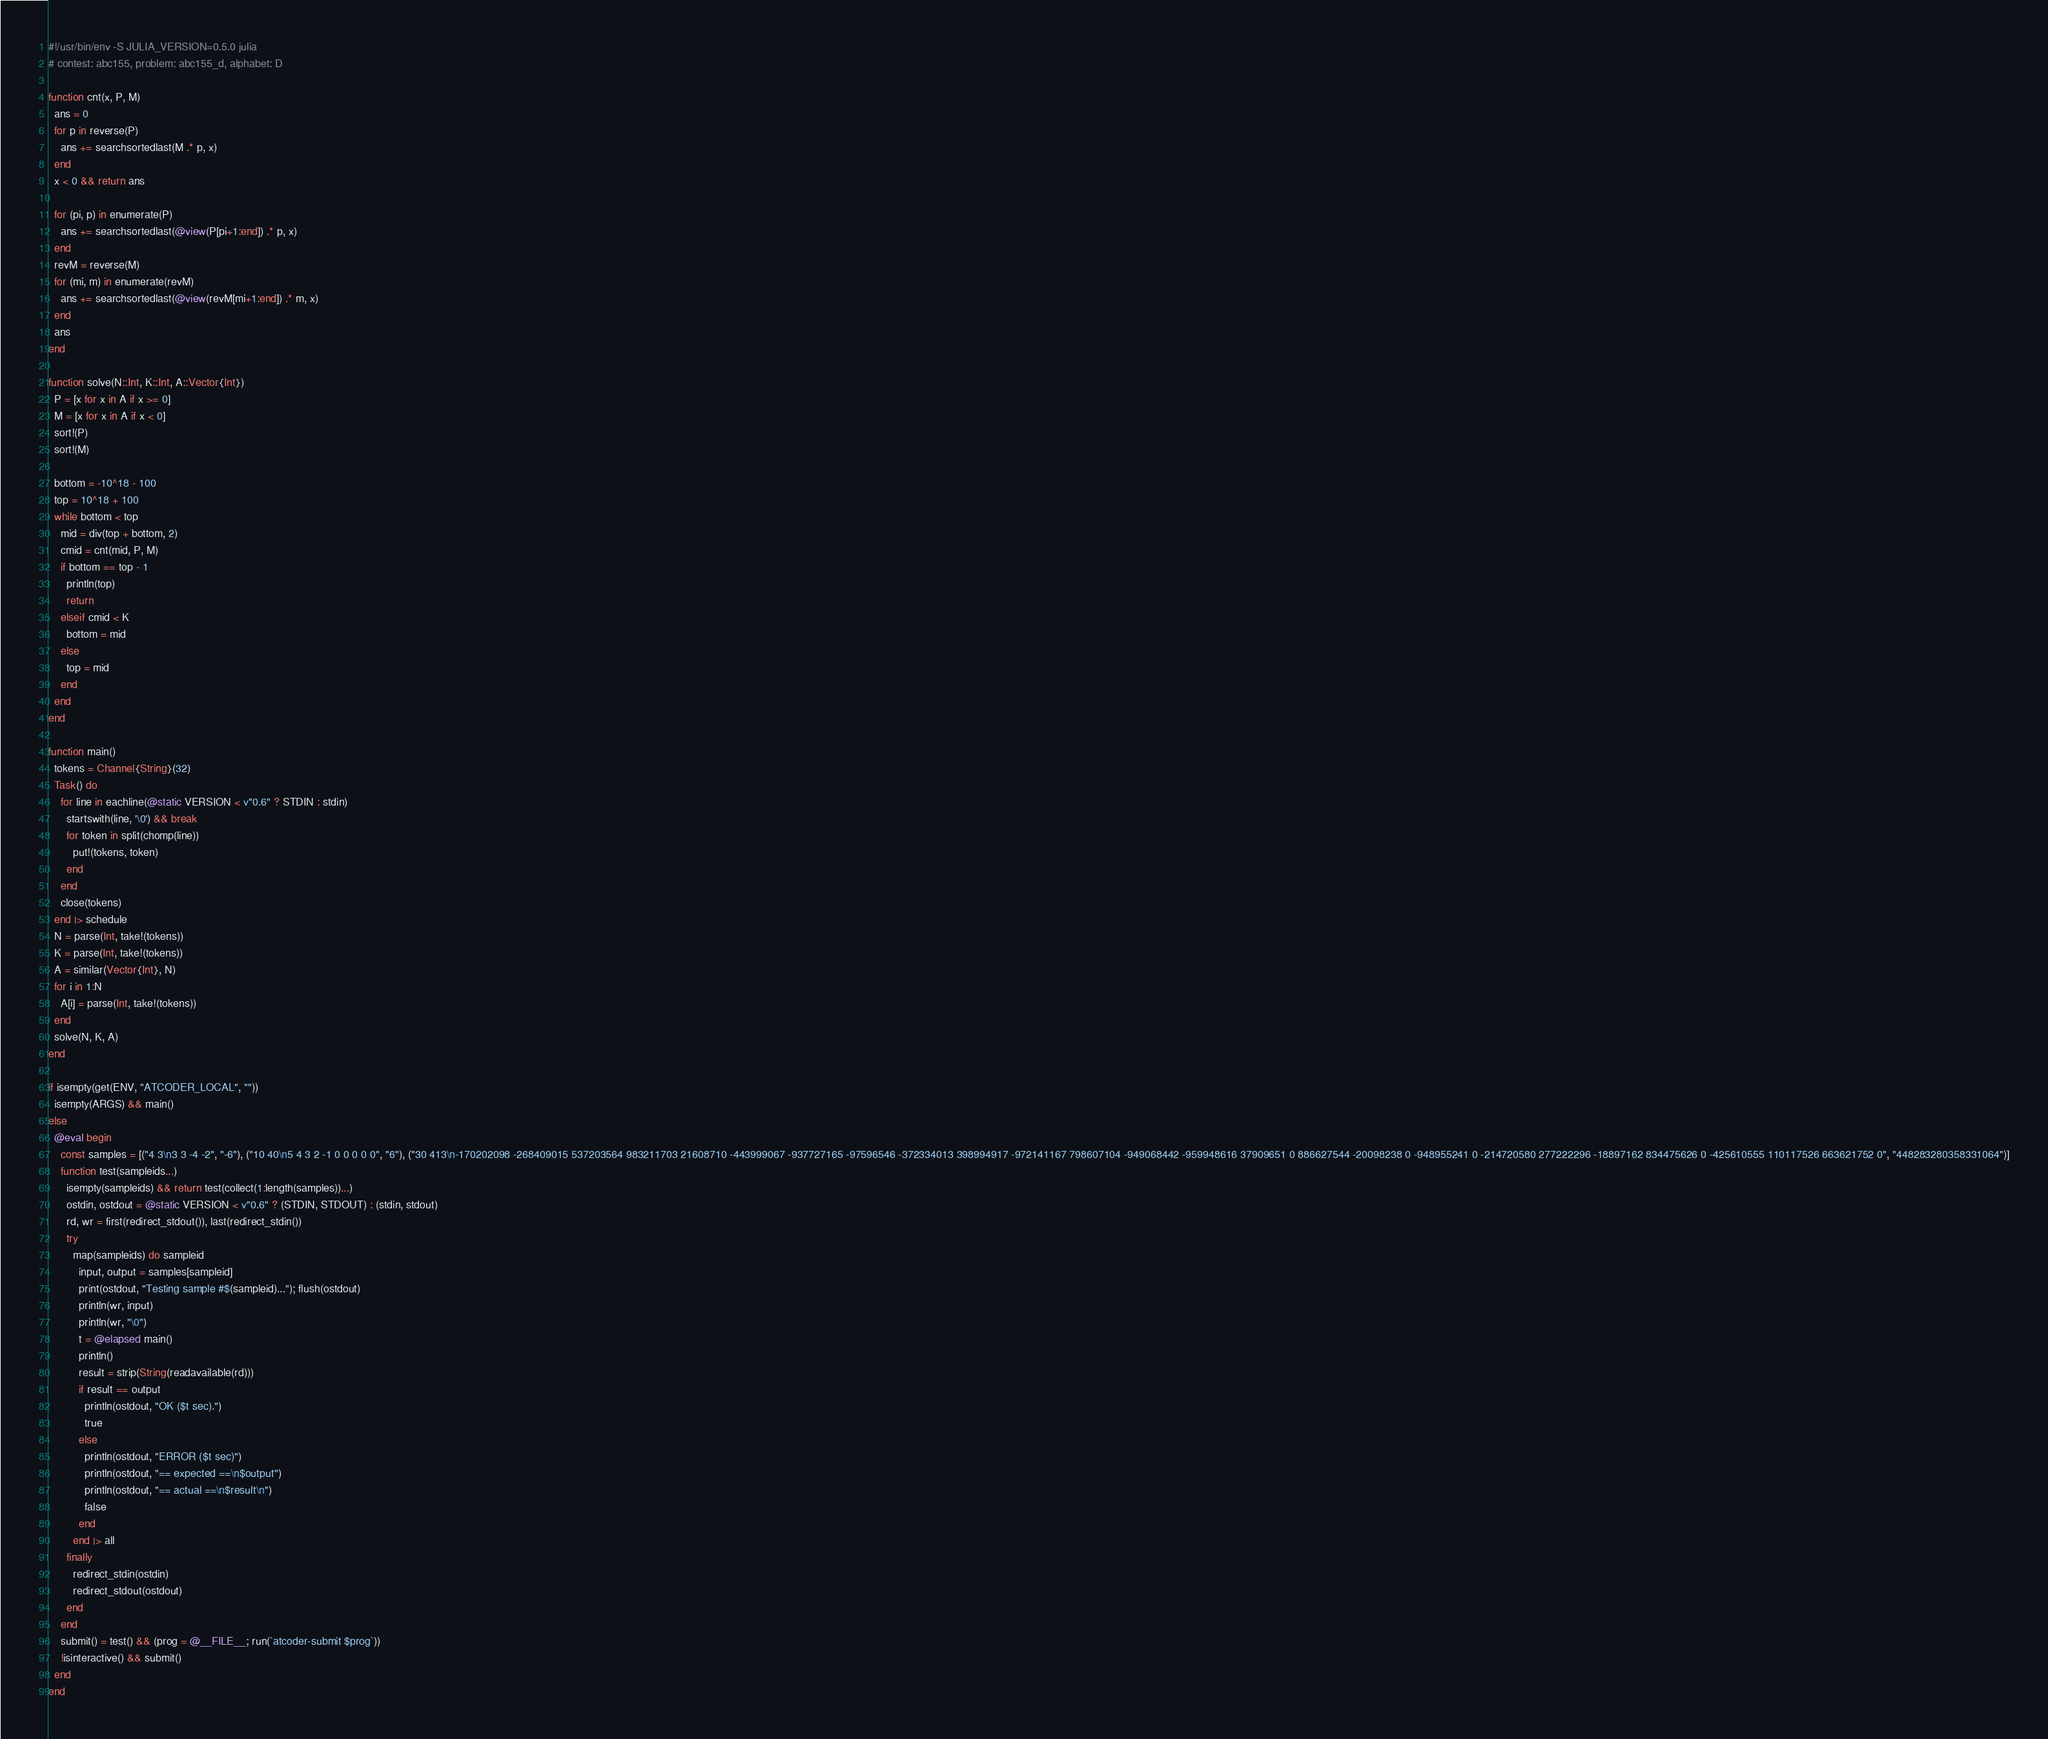Convert code to text. <code><loc_0><loc_0><loc_500><loc_500><_Julia_>#!/usr/bin/env -S JULIA_VERSION=0.5.0 julia
# contest: abc155, problem: abc155_d, alphabet: D

function cnt(x, P, M)
  ans = 0
  for p in reverse(P)
    ans += searchsortedlast(M .* p, x)
  end
  x < 0 && return ans

  for (pi, p) in enumerate(P)
    ans += searchsortedlast(@view(P[pi+1:end]) .* p, x)
  end
  revM = reverse(M)
  for (mi, m) in enumerate(revM)
    ans += searchsortedlast(@view(revM[mi+1:end]) .* m, x)
  end
  ans
end

function solve(N::Int, K::Int, A::Vector{Int})
  P = [x for x in A if x >= 0]
  M = [x for x in A if x < 0]
  sort!(P)
  sort!(M)

  bottom = -10^18 - 100
  top = 10^18 + 100
  while bottom < top
    mid = div(top + bottom, 2)
    cmid = cnt(mid, P, M)
    if bottom == top - 1
      println(top)
      return
    elseif cmid < K
      bottom = mid
    else
      top = mid
    end
  end
end

function main()
  tokens = Channel{String}(32)
  Task() do
    for line in eachline(@static VERSION < v"0.6" ? STDIN : stdin)
      startswith(line, '\0') && break
      for token in split(chomp(line))
        put!(tokens, token)
      end
    end
    close(tokens)
  end |> schedule
  N = parse(Int, take!(tokens))
  K = parse(Int, take!(tokens))
  A = similar(Vector{Int}, N)
  for i in 1:N
    A[i] = parse(Int, take!(tokens))
  end
  solve(N, K, A)
end

if isempty(get(ENV, "ATCODER_LOCAL", ""))
  isempty(ARGS) && main()
else
  @eval begin
    const samples = [("4 3\n3 3 -4 -2", "-6"), ("10 40\n5 4 3 2 -1 0 0 0 0 0", "6"), ("30 413\n-170202098 -268409015 537203564 983211703 21608710 -443999067 -937727165 -97596546 -372334013 398994917 -972141167 798607104 -949068442 -959948616 37909651 0 886627544 -20098238 0 -948955241 0 -214720580 277222296 -18897162 834475626 0 -425610555 110117526 663621752 0", "448283280358331064")]
    function test(sampleids...)
      isempty(sampleids) && return test(collect(1:length(samples))...)
      ostdin, ostdout = @static VERSION < v"0.6" ? (STDIN, STDOUT) : (stdin, stdout)
      rd, wr = first(redirect_stdout()), last(redirect_stdin())
      try
        map(sampleids) do sampleid
          input, output = samples[sampleid]
          print(ostdout, "Testing sample #$(sampleid)..."); flush(ostdout)
          println(wr, input)
          println(wr, "\0")
          t = @elapsed main()
          println()
          result = strip(String(readavailable(rd)))
          if result == output
            println(ostdout, "OK ($t sec).")
            true
          else
            println(ostdout, "ERROR ($t sec)")
            println(ostdout, "== expected ==\n$output")
            println(ostdout, "== actual ==\n$result\n")
            false
          end
        end |> all
      finally
        redirect_stdin(ostdin)
        redirect_stdout(ostdout)
      end
    end
    submit() = test() && (prog = @__FILE__; run(`atcoder-submit $prog`))
    !isinteractive() && submit()
  end
end
</code> 